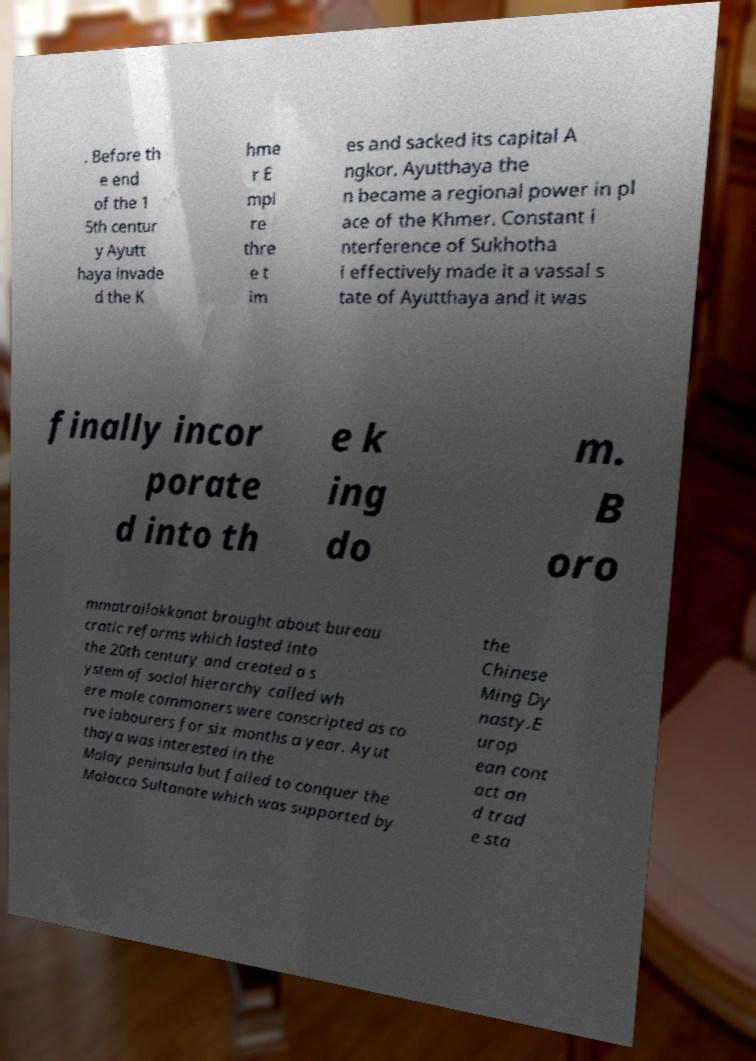Can you read and provide the text displayed in the image?This photo seems to have some interesting text. Can you extract and type it out for me? . Before th e end of the 1 5th centur y Ayutt haya invade d the K hme r E mpi re thre e t im es and sacked its capital A ngkor. Ayutthaya the n became a regional power in pl ace of the Khmer. Constant i nterference of Sukhotha i effectively made it a vassal s tate of Ayutthaya and it was finally incor porate d into th e k ing do m. B oro mmatrailokkanat brought about bureau cratic reforms which lasted into the 20th century and created a s ystem of social hierarchy called wh ere male commoners were conscripted as co rve labourers for six months a year. Ayut thaya was interested in the Malay peninsula but failed to conquer the Malacca Sultanate which was supported by the Chinese Ming Dy nasty.E urop ean cont act an d trad e sta 